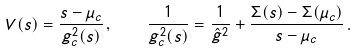<formula> <loc_0><loc_0><loc_500><loc_500>V ( s ) = \frac { s - \mu _ { c } } { g _ { c } ^ { 2 } ( s ) } \, , \quad \frac { 1 } { g _ { c } ^ { 2 } ( s ) } = \frac { 1 } { \hat { g } ^ { 2 } } + \frac { \Sigma ( s ) - \Sigma ( \mu _ { c } ) } { s - \mu _ { c } } \, .</formula> 